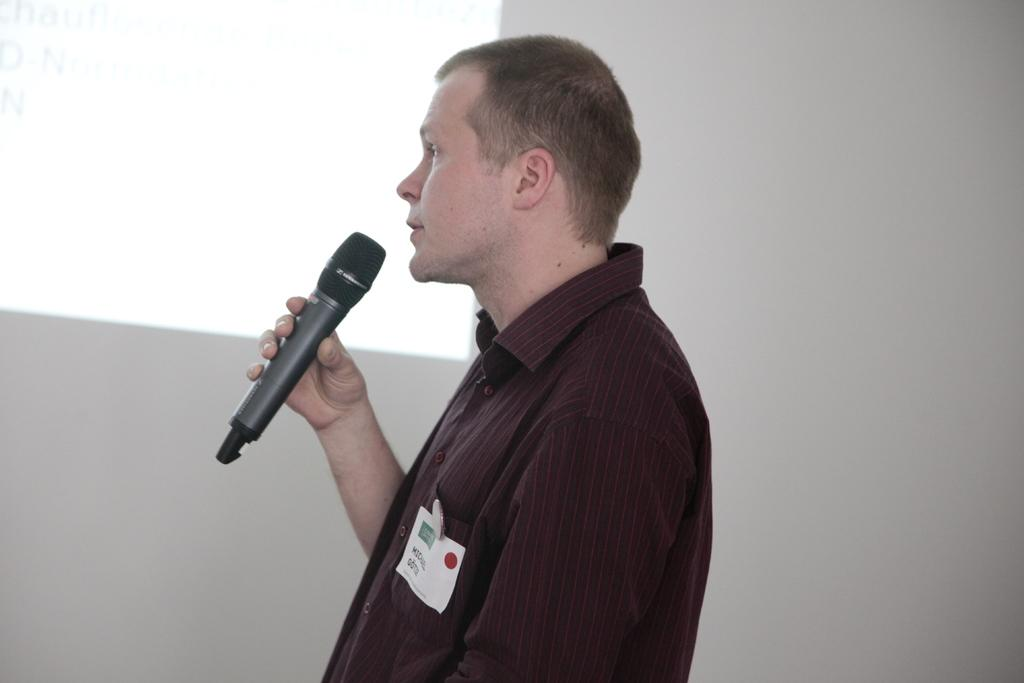What is the main subject of the image? There is a person in the image. What is the person wearing? The person is wearing a maroon shirt. What is the person holding in the image? The person is holding a mic. What other object can be seen in the image? There is a paper in the image. What is visible in the background of the image? There is a screen in the background of the image. How many chairs are visible in the image? There are no chairs visible in the image. What type of control does the person have over the screen in the background? There is no indication in the image that the person has any control over the screen in the background. 